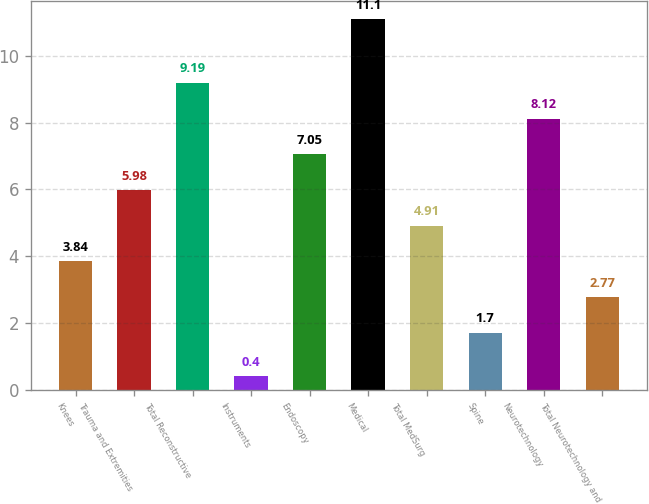Convert chart. <chart><loc_0><loc_0><loc_500><loc_500><bar_chart><fcel>Knees<fcel>Trauma and Extremities<fcel>Total Reconstructive<fcel>Instruments<fcel>Endoscopy<fcel>Medical<fcel>Total MedSurg<fcel>Spine<fcel>Neurotechnology<fcel>Total Neurotechnology and<nl><fcel>3.84<fcel>5.98<fcel>9.19<fcel>0.4<fcel>7.05<fcel>11.1<fcel>4.91<fcel>1.7<fcel>8.12<fcel>2.77<nl></chart> 